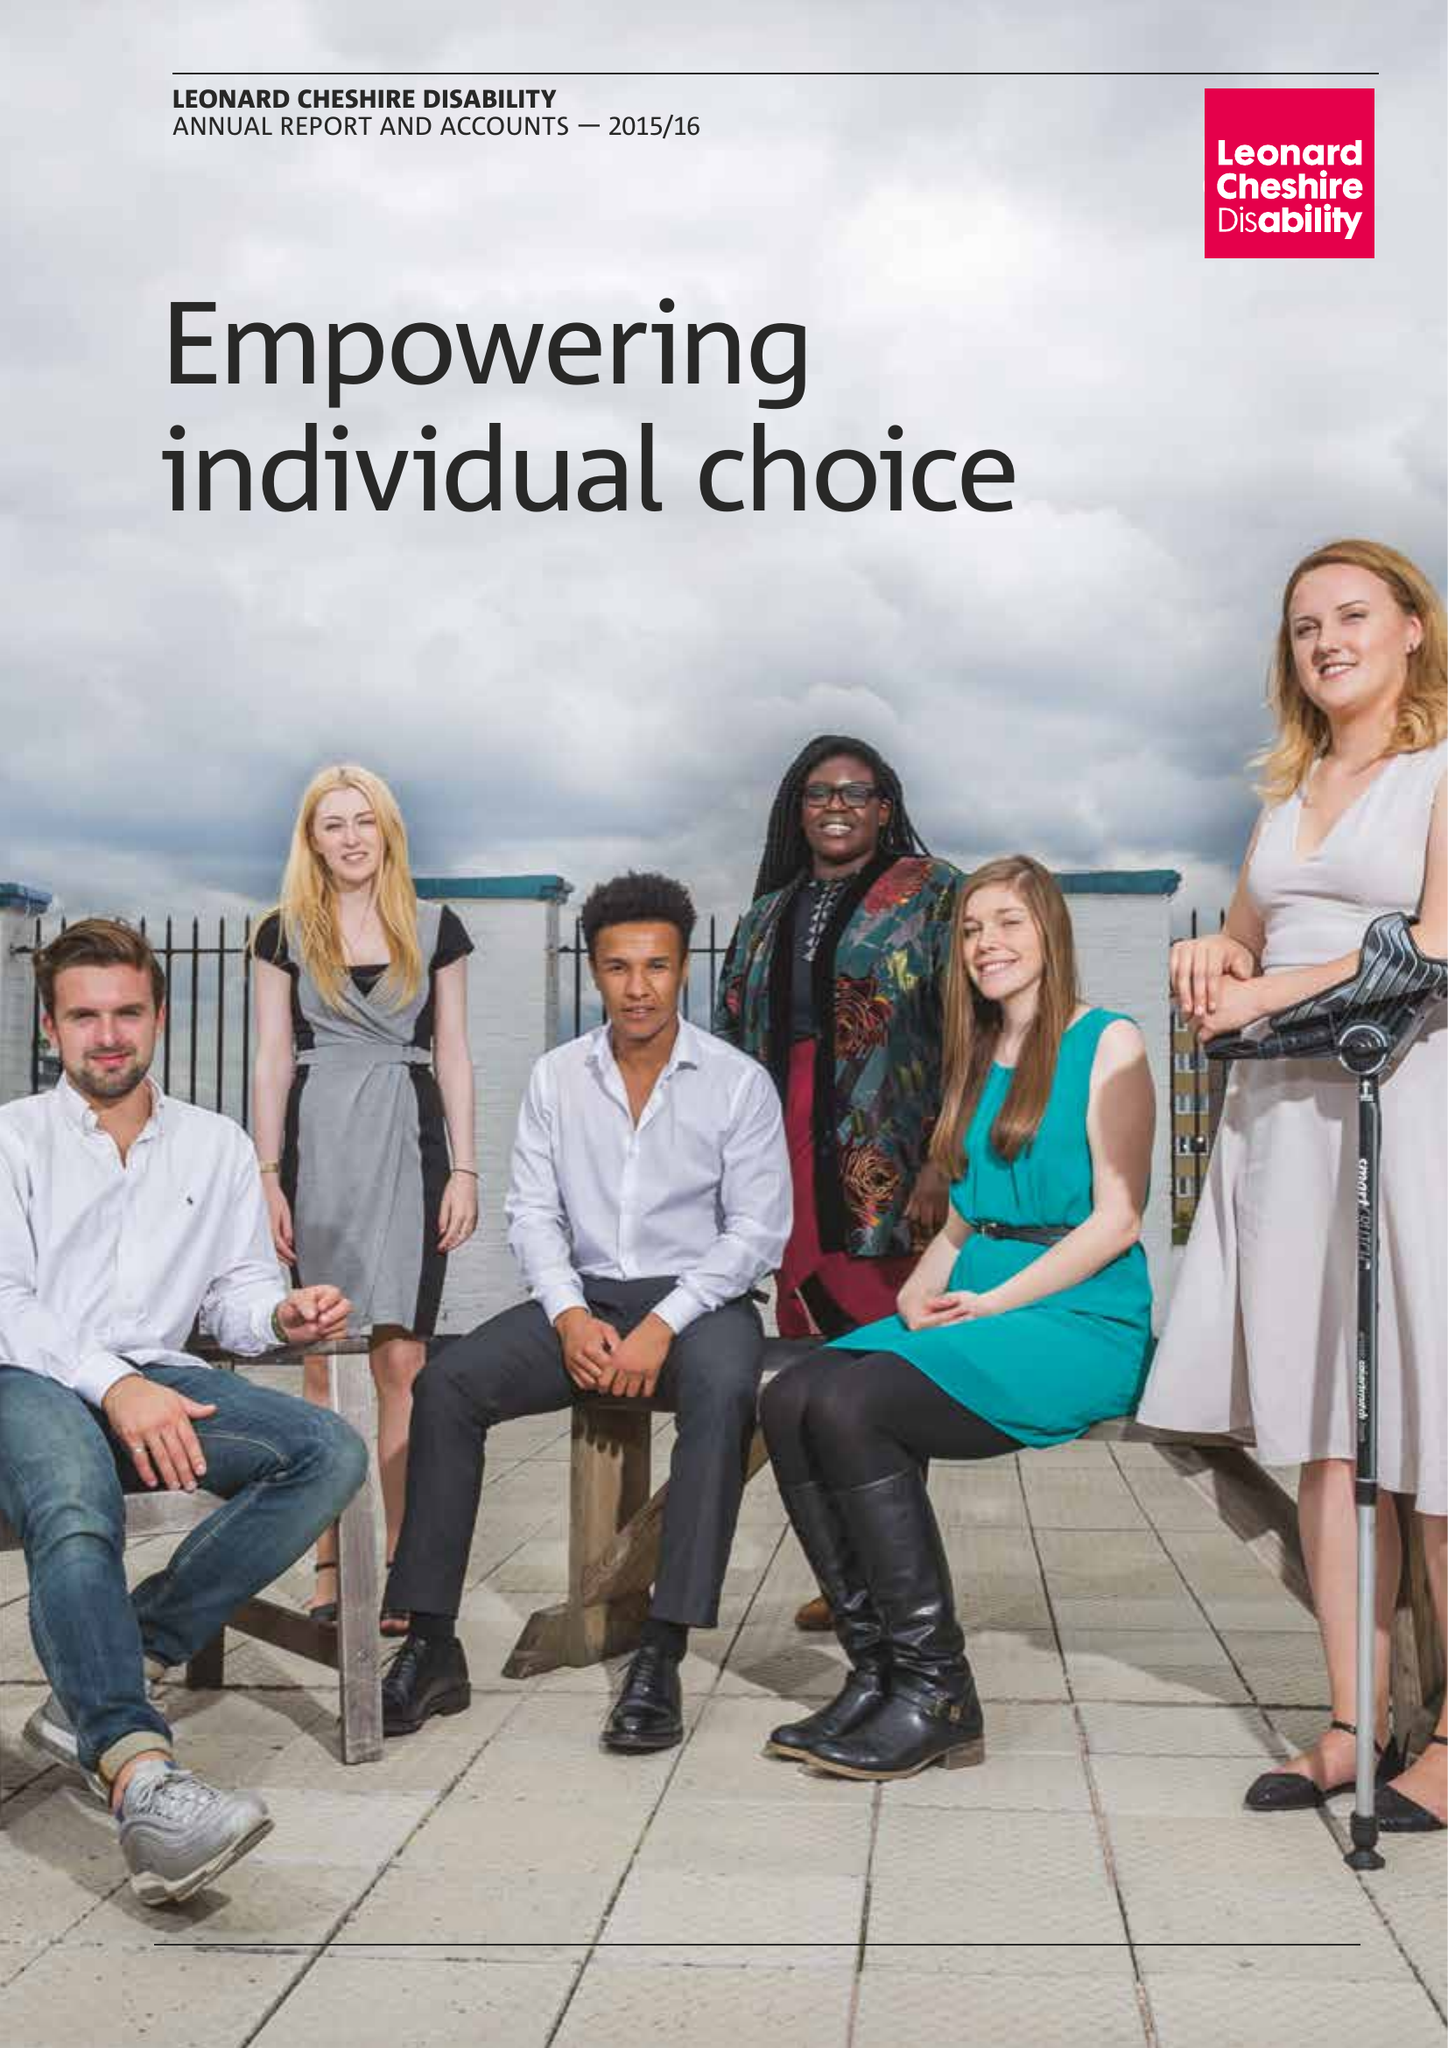What is the value for the report_date?
Answer the question using a single word or phrase. 2016-03-31 